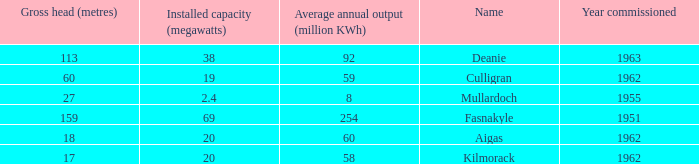What is the Average annual output for Culligran power station with an Installed capacity less than 19? None. 